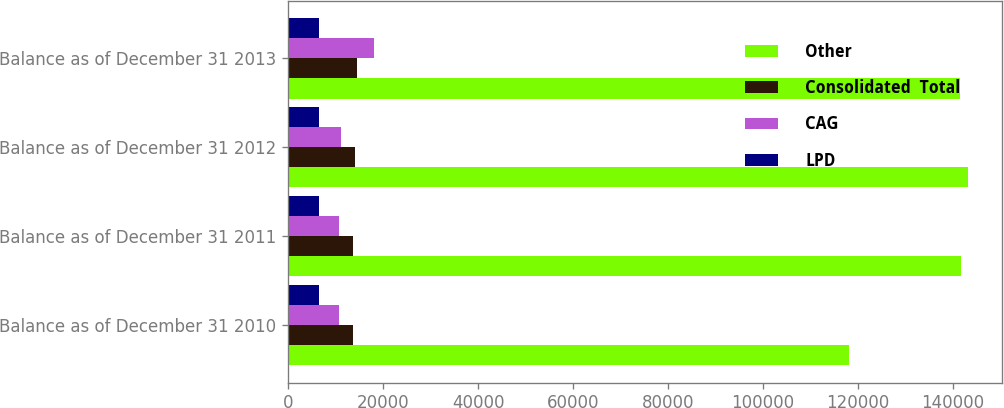Convert chart. <chart><loc_0><loc_0><loc_500><loc_500><stacked_bar_chart><ecel><fcel>Balance as of December 31 2010<fcel>Balance as of December 31 2011<fcel>Balance as of December 31 2012<fcel>Balance as of December 31 2013<nl><fcel>Other<fcel>118131<fcel>141677<fcel>143155<fcel>141408<nl><fcel>Consolidated  Total<fcel>13648<fcel>13576<fcel>14179<fcel>14515<nl><fcel>CAG<fcel>10802<fcel>10826<fcel>11129<fcel>18067<nl><fcel>LPD<fcel>6531<fcel>6531<fcel>6531<fcel>6531<nl></chart> 